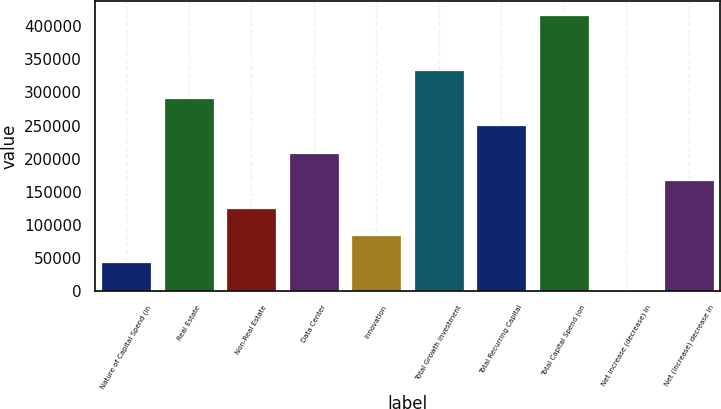Convert chart to OTSL. <chart><loc_0><loc_0><loc_500><loc_500><bar_chart><fcel>Nature of Capital Spend (in<fcel>Real Estate<fcel>Non-Real Estate<fcel>Data Center<fcel>Innovation<fcel>Total Growth Investment<fcel>Total Recurring Capital<fcel>Total Capital Spend (on<fcel>Net increase (decrease) in<fcel>Net (increase) decrease in<nl><fcel>43134.1<fcel>292165<fcel>126144<fcel>209154<fcel>84639.2<fcel>333670<fcel>250660<fcel>416680<fcel>1629<fcel>167649<nl></chart> 